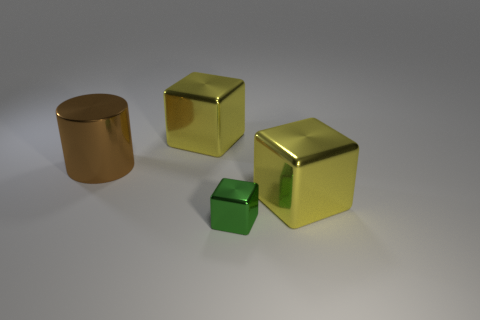What color is the metallic object that is on the right side of the object in front of the big yellow metallic thing that is in front of the brown shiny cylinder?
Make the answer very short. Yellow. Is there anything else that has the same size as the green block?
Provide a short and direct response. No. What color is the big cylinder?
Your answer should be compact. Brown. What is the shape of the yellow metallic object that is left of the yellow shiny thing on the right side of the big yellow block that is left of the green metallic cube?
Give a very brief answer. Cube. How many other things are there of the same color as the tiny shiny cube?
Offer a terse response. 0. Are there more large objects that are on the left side of the tiny green metal thing than cylinders that are in front of the large brown object?
Your answer should be very brief. Yes. There is a large brown metallic thing; are there any yellow blocks in front of it?
Give a very brief answer. Yes. What is the large thing that is to the right of the large brown metallic thing and on the left side of the green metal object made of?
Your answer should be very brief. Metal. Is there a cube that is to the right of the large cube that is on the left side of the green block?
Offer a terse response. Yes. The green cube has what size?
Your answer should be compact. Small. 